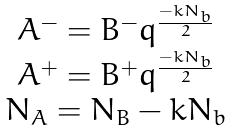Convert formula to latex. <formula><loc_0><loc_0><loc_500><loc_500>\begin{array} { c } A ^ { - } = B ^ { - } q ^ { \frac { - k N _ { b } } { 2 } } \\ A ^ { + } = B ^ { + } q ^ { \frac { - k N _ { b } } { 2 } } \\ N _ { A } = N _ { B } - k N _ { b } \end{array}</formula> 